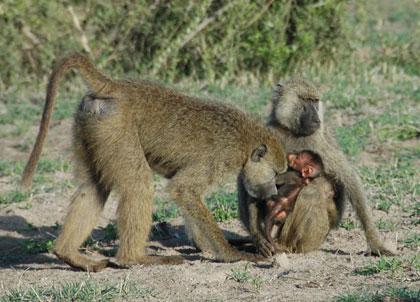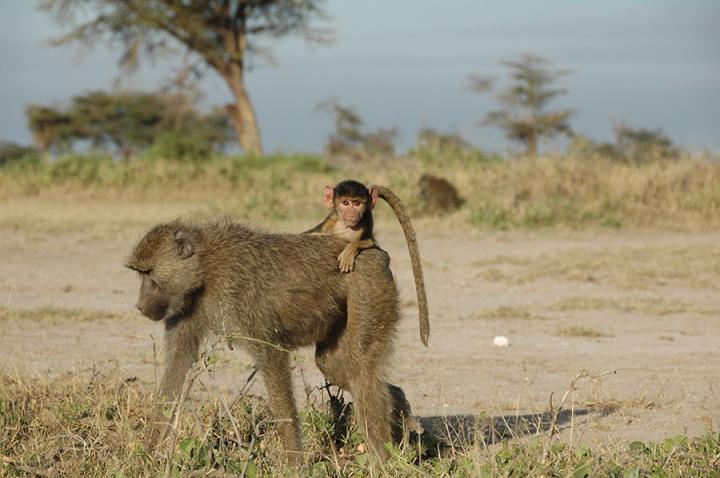The first image is the image on the left, the second image is the image on the right. Evaluate the accuracy of this statement regarding the images: "There are three monkeys in the pair of images.". Is it true? Answer yes or no. No. The first image is the image on the left, the second image is the image on the right. Analyze the images presented: Is the assertion "An image includes a leftward-moving adult baboon walking on all fours, and each image includes one baboon on all fours." valid? Answer yes or no. Yes. 